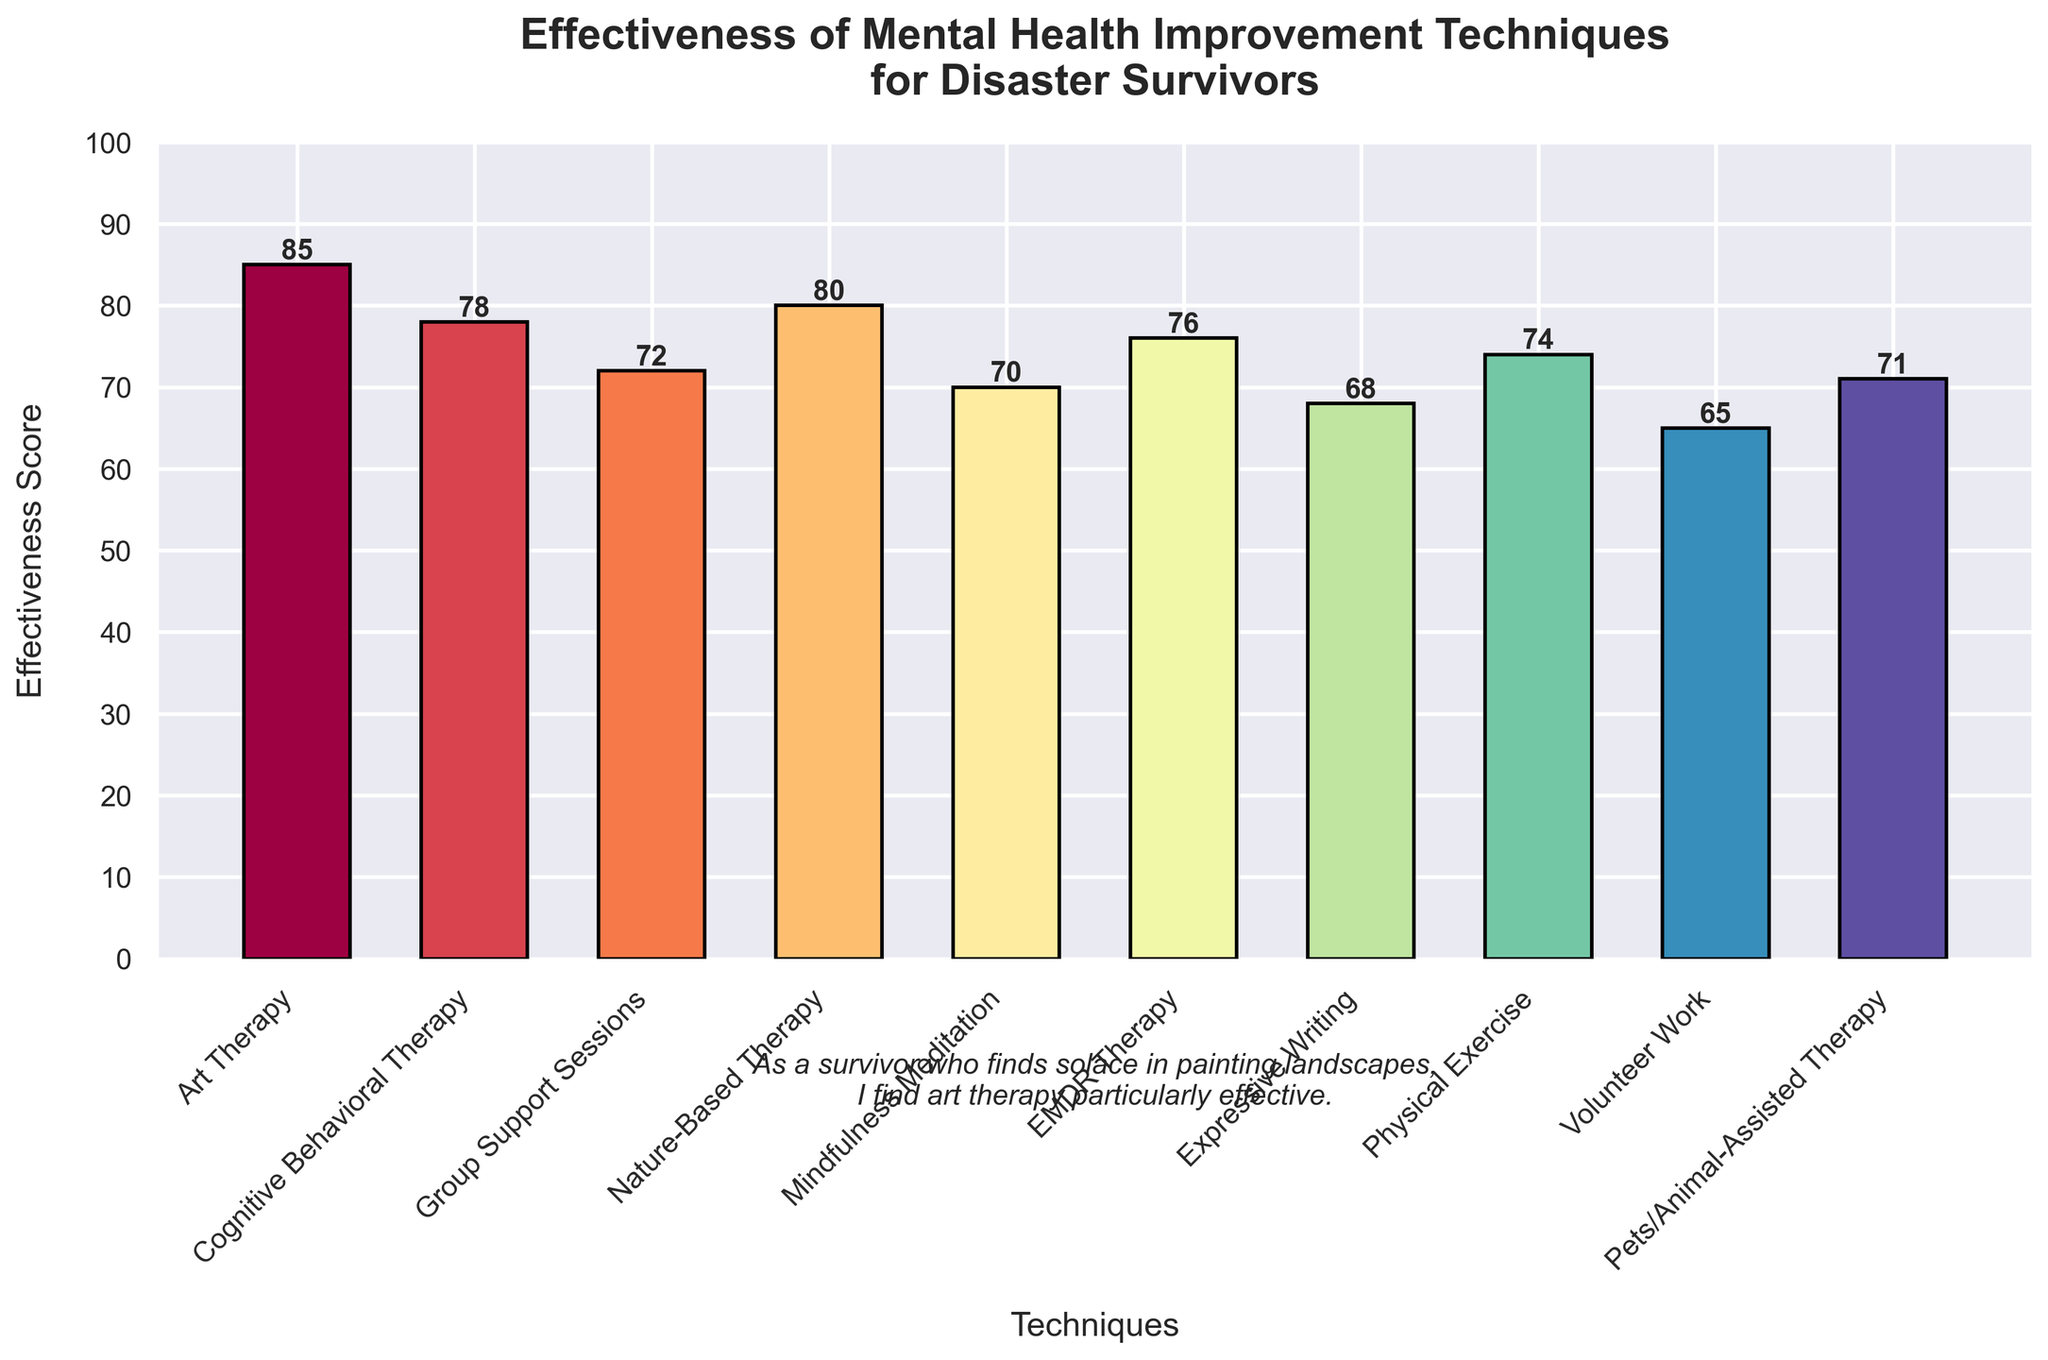What's the most effective mental health improvement technique for disaster survivors? The figure shows that Art Therapy has the highest effectiveness score among the listed techniques. By observing the bar heights, Art Therapy stands tallest with a score of 85.
Answer: Art Therapy Which technique has a higher effectiveness score, Cognitive Behavioral Therapy or Mindfulness Meditation? The bar for Cognitive Behavioral Therapy reaches 78, while Mindfulness Meditation's bar reaches 70. Comparing the heights, Cognitive Behavioral Therapy has a higher score.
Answer: Cognitive Behavioral Therapy What is the average effectiveness score of all the techniques mentioned? The scores are 85, 78, 72, 80, 70, 76, 68, 74, 65, and 71. Summing these gives 739. Dividing by the number of techniques (10) gives an average score of 739/10.
Answer: 73.9 How many techniques have an effectiveness score higher than 75? The techniques with scores above 75 are Art Therapy (85), Cognitive Behavioral Therapy (78), Nature-Based Therapy (80), and EMDR Therapy (76). Counting them totals to four techniques.
Answer: 4 Which technique is the least effective for mental health improvement according to the figure? The shortest bar represents Volunteer Work, which has the lowest effectiveness score of 65.
Answer: Volunteer Work Compare the effectiveness of Nature-Based Therapy and Group Support Sessions. Which one is more effective and by how much? Nature-Based Therapy has an effectiveness score of 80, while Group Support Sessions have a score of 72. The difference between them is 80 - 72 = 8. Nature-Based Therapy is more effective by 8 points.
Answer: Nature-Based Therapy, 8 points Arrange the techniques in descending order of their effectiveness scores. The scores in descending order are: Art Therapy (85), Nature-Based Therapy (80), Cognitive Behavioral Therapy (78), EMDR Therapy (76), Physical Exercise (74), Group Support Sessions (72), Pets/Animal-Assisted Therapy (71), Mindfulness Meditation (70), Expressive Writing (68), Volunteer Work (65).
Answer: Art Therapy, Nature-Based Therapy, Cognitive Behavioral Therapy, EMDR Therapy, Physical Exercise, Group Support Sessions, Pets/Animal-Assisted Therapy, Mindfulness Meditation, Expressive Writing, Volunteer Work What is the median effectiveness score of the techniques? Arranging the scores in ascending order: 65, 68, 70, 71, 72, 74, 76, 78, 80, 85. The median lies between the 5th and 6th scores (72 and 74), so (72 + 74)/2 = 73.
Answer: 73 What is the difference between the most effective and the least effective technique? Art Therapy has the highest score of 85, and Volunteer Work the lowest with 65. The difference between these scores is 85 - 65.
Answer: 20 